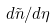Convert formula to latex. <formula><loc_0><loc_0><loc_500><loc_500>d \tilde { n } / d \eta</formula> 